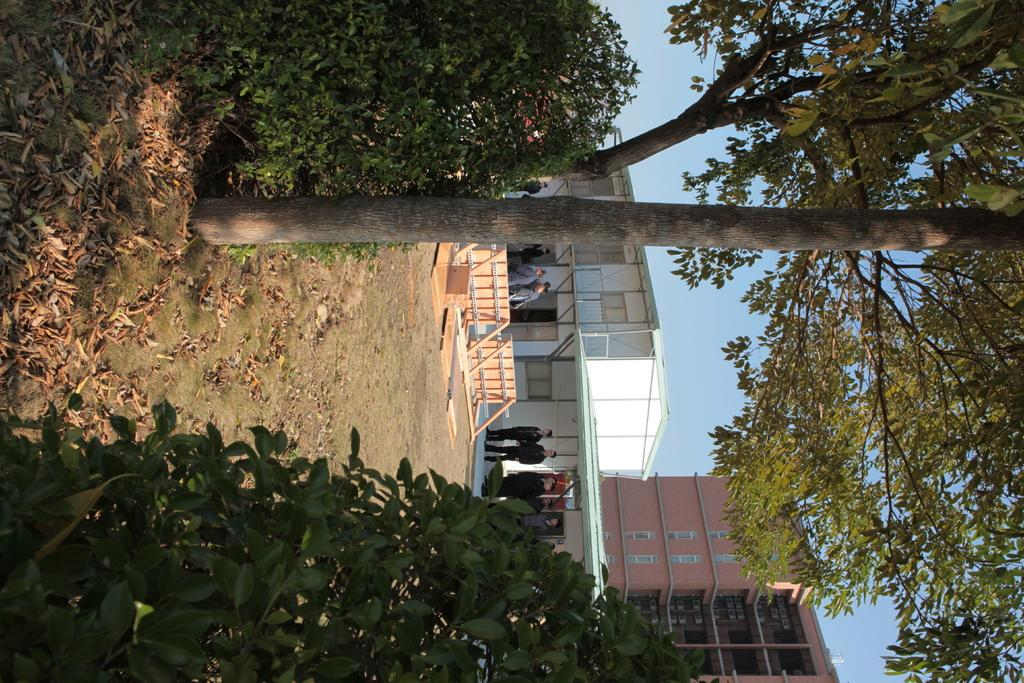What can be seen in the middle of the image? There are buildings, trees, bushes, and some persons standing in the middle of the image. Can you describe the vegetation present in the image? There are trees and bushes in the middle of the image. How many types of structures are visible in the image? There are two types of structures visible in the image: buildings and trees. What are the persons in the image doing? The provided facts do not specify what the persons are doing in the image. What type of cord is being used to tie the banana to the tank in the image? There is no banana or tank present in the image. What color is the cord used to tie the banana to the tank in the image? Since there is no banana or tank present in the image, there is no cord to describe. 